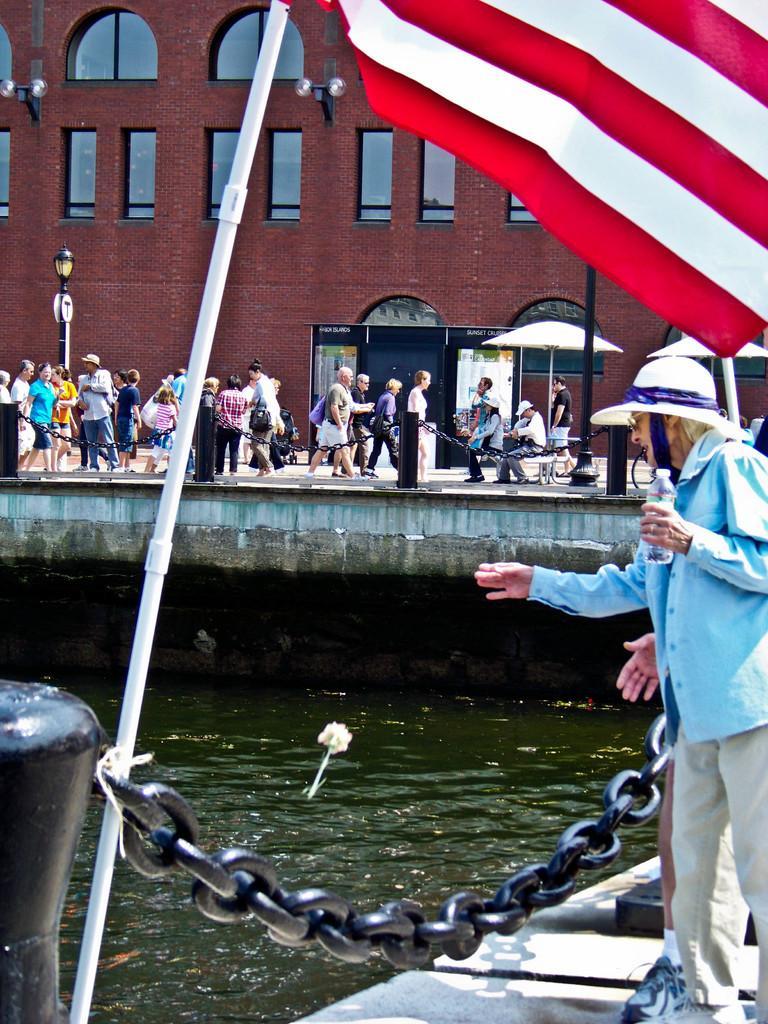How would you summarize this image in a sentence or two? On the right side, I can see a man and another person are standing on the boat facing towards the left side. The man is holding a bottle in the hand. Beside these persons I can see a metal chain which is attached to a rod. On the left side, I can see a flag. In the middle of the image I can see the water. In the background there are few people walking on the ground and also I can see a red color building along with the windows. 